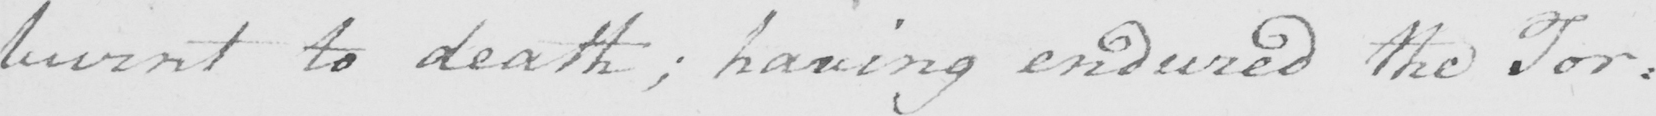Can you read and transcribe this handwriting? burnt to death ; having endured the Tor : 